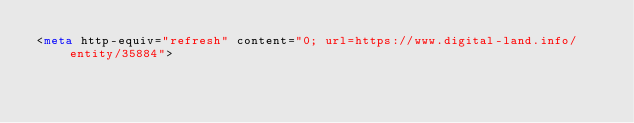Convert code to text. <code><loc_0><loc_0><loc_500><loc_500><_HTML_><meta http-equiv="refresh" content="0; url=https://www.digital-land.info/entity/35884"></code> 